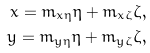<formula> <loc_0><loc_0><loc_500><loc_500>x = m _ { x \eta } \eta + m _ { x \zeta } \zeta , \\ y = m _ { y \eta } \eta + m _ { y \zeta } \zeta ,</formula> 